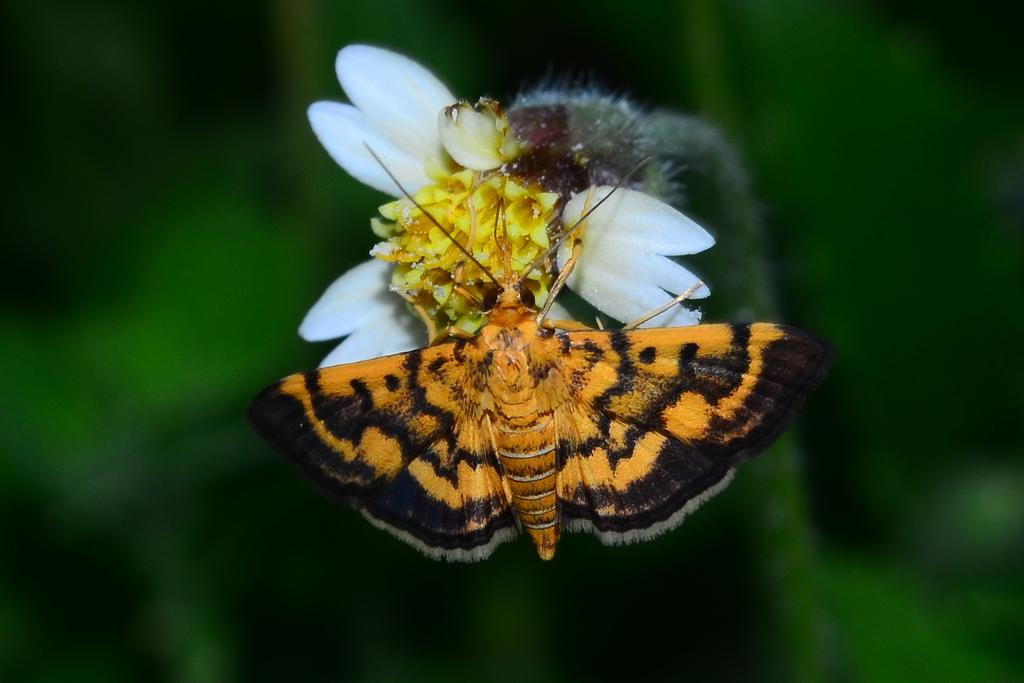What is the main subject of the image? There is a butterfly in the image. Where is the butterfly located in the image? The butterfly is sitting on a white flower. Can you describe the background of the image? The background of the image is blurred. What type of word can be seen on the butterfly's wings in the image? There are no words visible on the butterfly's wings in the image. How many toes does the butterfly have in the image? Butterflies do not have toes, as they are insects with six legs. 